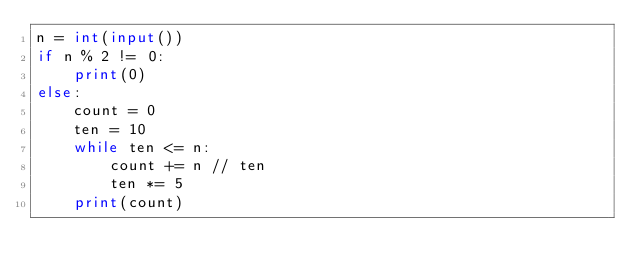Convert code to text. <code><loc_0><loc_0><loc_500><loc_500><_Python_>n = int(input())
if n % 2 != 0:
    print(0)
else:
    count = 0
    ten = 10
    while ten <= n:
        count += n // ten
        ten *= 5
    print(count)</code> 